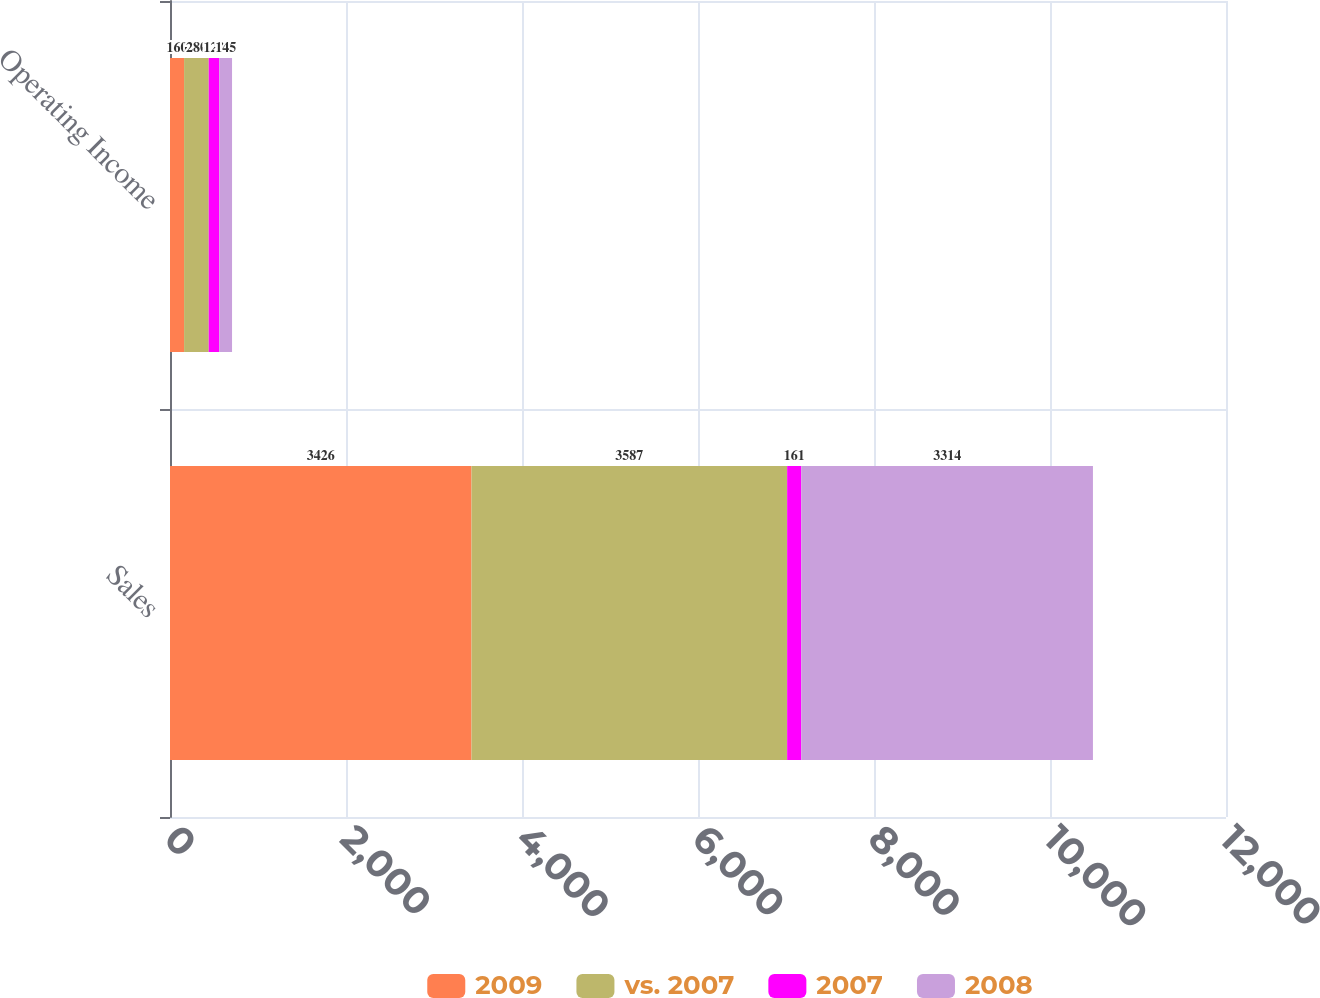Convert chart to OTSL. <chart><loc_0><loc_0><loc_500><loc_500><stacked_bar_chart><ecel><fcel>Sales<fcel>Operating Income<nl><fcel>2009<fcel>3426<fcel>160<nl><fcel>vs. 2007<fcel>3587<fcel>280<nl><fcel>2007<fcel>161<fcel>120<nl><fcel>2008<fcel>3314<fcel>145<nl></chart> 